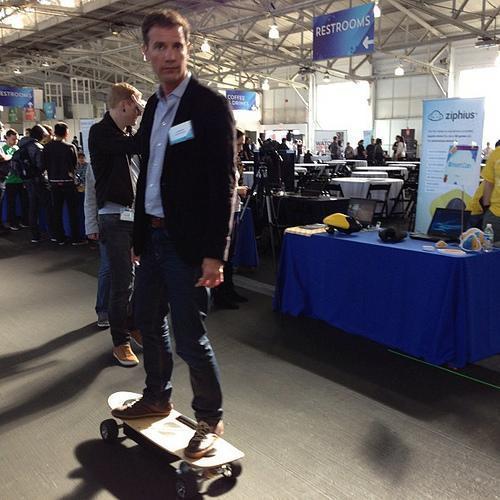How many people are on a skateboard?
Give a very brief answer. 1. 